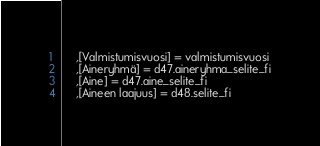Convert code to text. <code><loc_0><loc_0><loc_500><loc_500><_SQL_>	,[Valmistumisvuosi] = valmistumisvuosi
	,[Aineryhmä] = d47.aineryhma_selite_fi
	,[Aine] = d47.aine_selite_fi
	,[Aineen laajuus] = d48.selite_fi</code> 